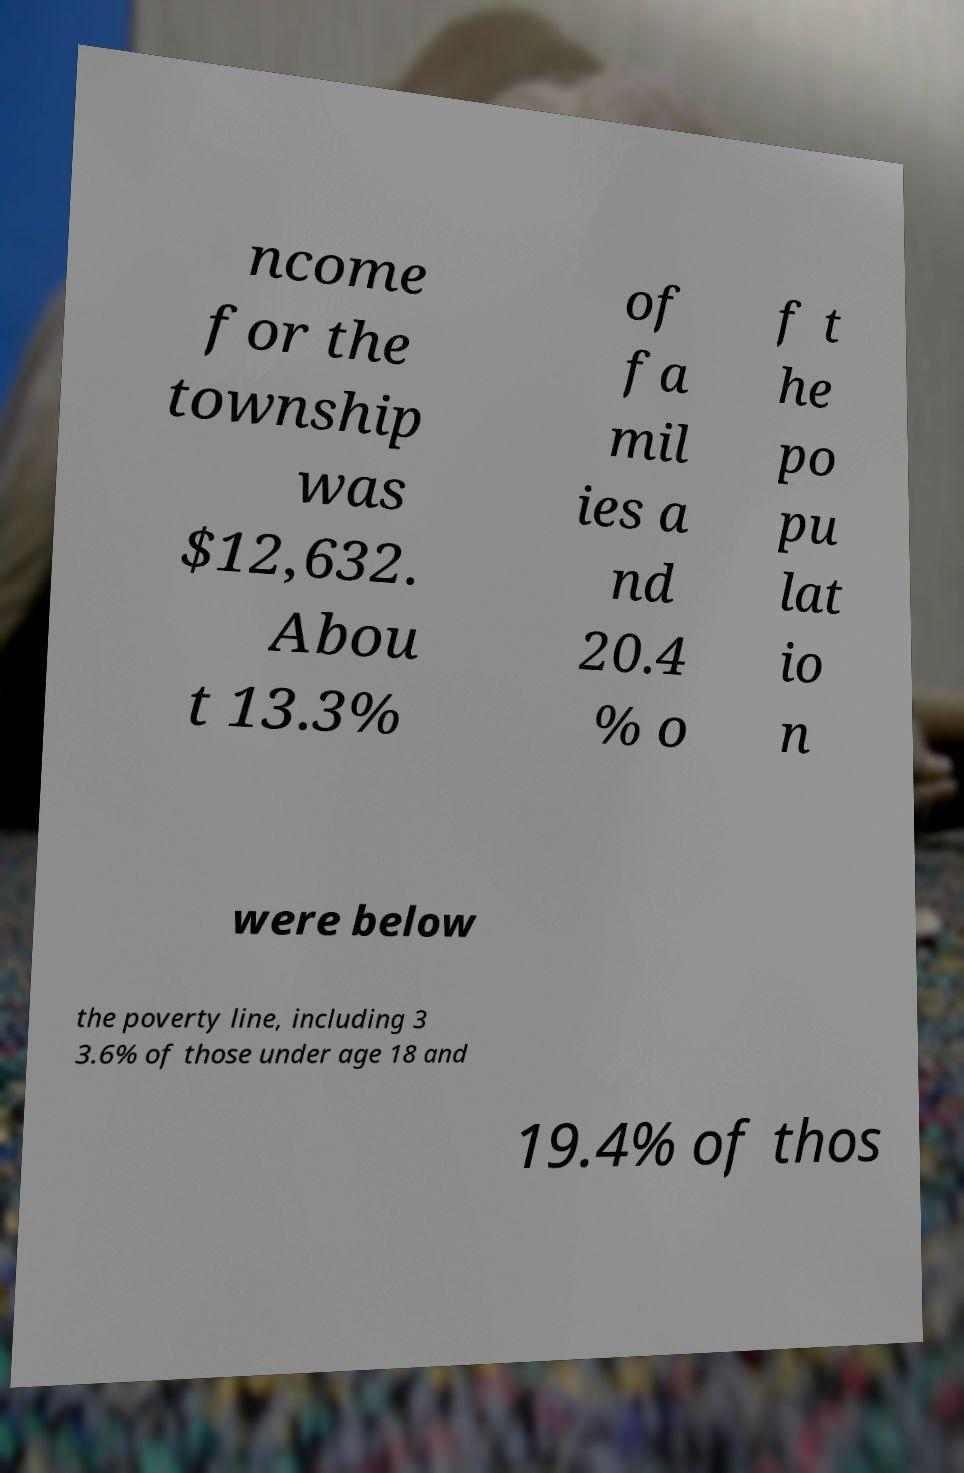Can you accurately transcribe the text from the provided image for me? ncome for the township was $12,632. Abou t 13.3% of fa mil ies a nd 20.4 % o f t he po pu lat io n were below the poverty line, including 3 3.6% of those under age 18 and 19.4% of thos 